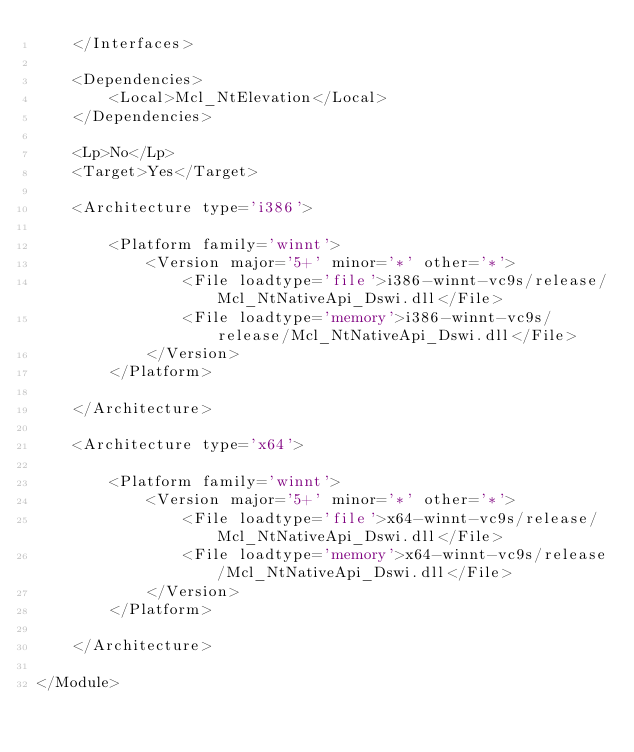<code> <loc_0><loc_0><loc_500><loc_500><_XML_>	</Interfaces>

	<Dependencies>
		<Local>Mcl_NtElevation</Local>
	</Dependencies>

	<Lp>No</Lp>
	<Target>Yes</Target>

	<Architecture type='i386'>

		<Platform family='winnt'>
		    <Version major='5+' minor='*' other='*'>
		        <File loadtype='file'>i386-winnt-vc9s/release/Mcl_NtNativeApi_Dswi.dll</File>
		        <File loadtype='memory'>i386-winnt-vc9s/release/Mcl_NtNativeApi_Dswi.dll</File>
		    </Version>
		</Platform>

	</Architecture>

	<Architecture type='x64'>

		<Platform family='winnt'>
		    <Version major='5+' minor='*' other='*'>
		        <File loadtype='file'>x64-winnt-vc9s/release/Mcl_NtNativeApi_Dswi.dll</File>
		        <File loadtype='memory'>x64-winnt-vc9s/release/Mcl_NtNativeApi_Dswi.dll</File>
		    </Version>
		</Platform>

	</Architecture>
	
</Module>
</code> 